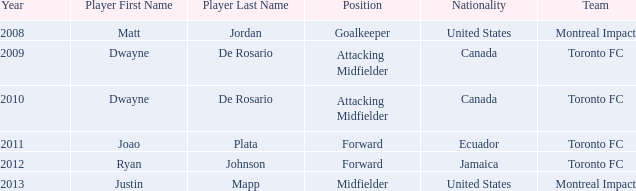After 2009, who was the player that has a nationality of Canada? Dwayne De Rosario Category:Articles with hCards. 